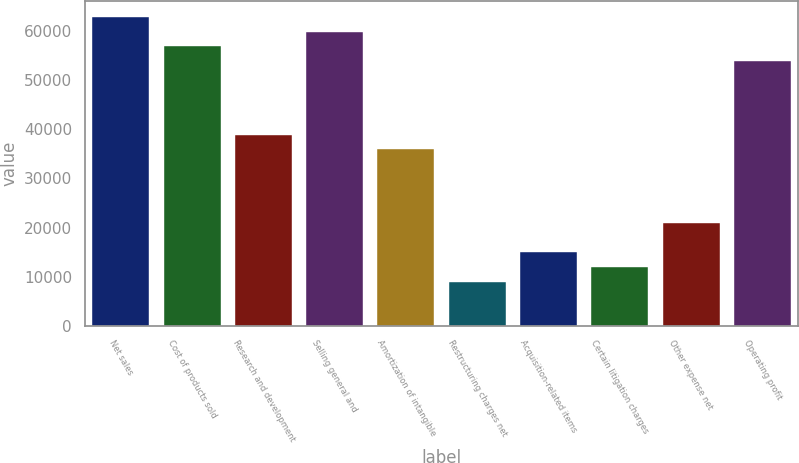<chart> <loc_0><loc_0><loc_500><loc_500><bar_chart><fcel>Net sales<fcel>Cost of products sold<fcel>Research and development<fcel>Selling general and<fcel>Amortization of intangible<fcel>Restructuring charges net<fcel>Acquisition-related items<fcel>Certain litigation charges<fcel>Other expense net<fcel>Operating profit<nl><fcel>62899.4<fcel>56909.1<fcel>38938.4<fcel>59904.2<fcel>35943.3<fcel>8987.2<fcel>14977.4<fcel>11982.3<fcel>20967.7<fcel>53914<nl></chart> 